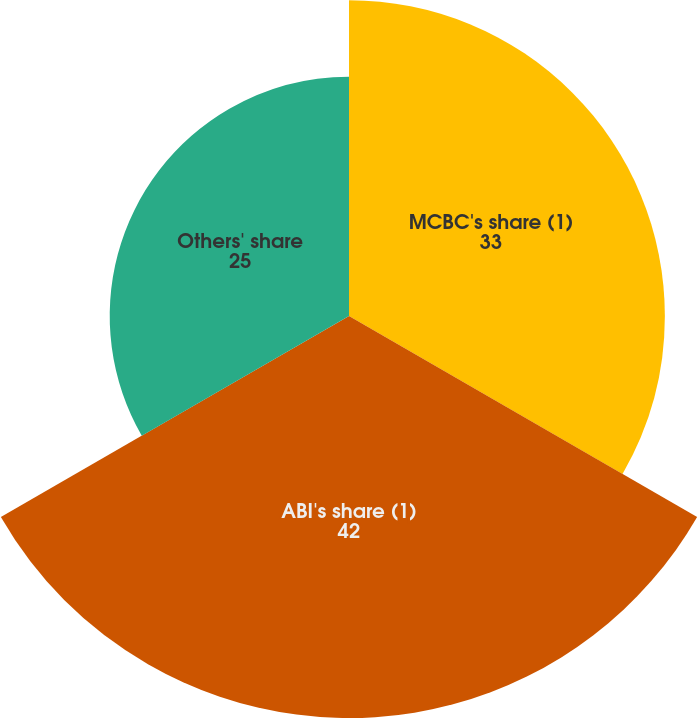Convert chart to OTSL. <chart><loc_0><loc_0><loc_500><loc_500><pie_chart><fcel>MCBC's share (1)<fcel>ABI's share (1)<fcel>Others' share<nl><fcel>33.0%<fcel>42.0%<fcel>25.0%<nl></chart> 